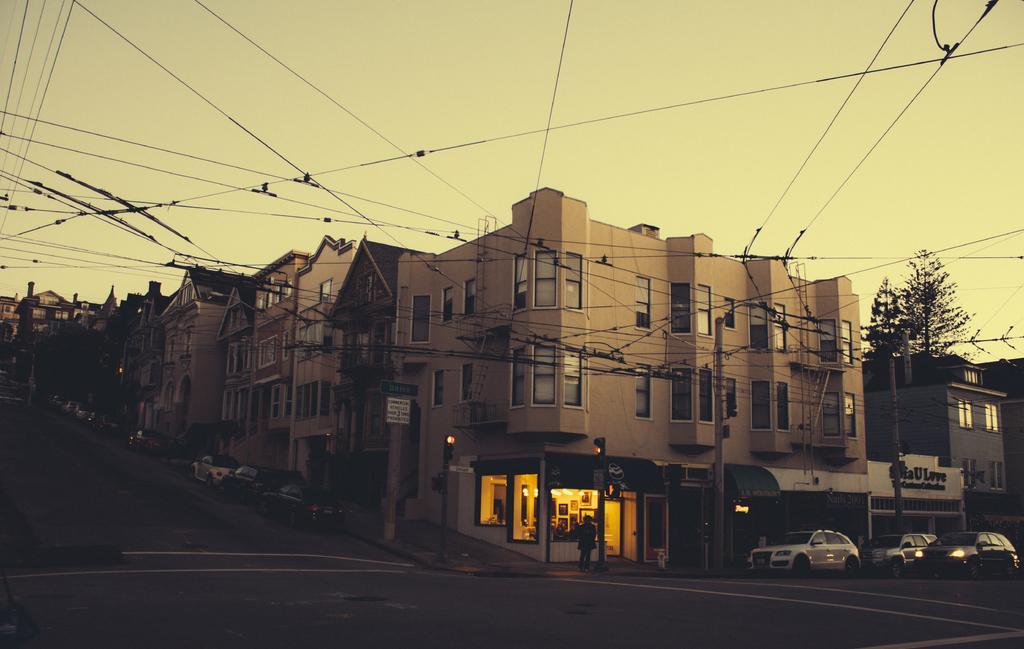Could you give a brief overview of what you see in this image? Here in this picture we can see houses and buildings present all over there and on the road we can see number of cars present and we can see electric poles here and there with wires connected to it all over there and we can also see trees present here and there. 